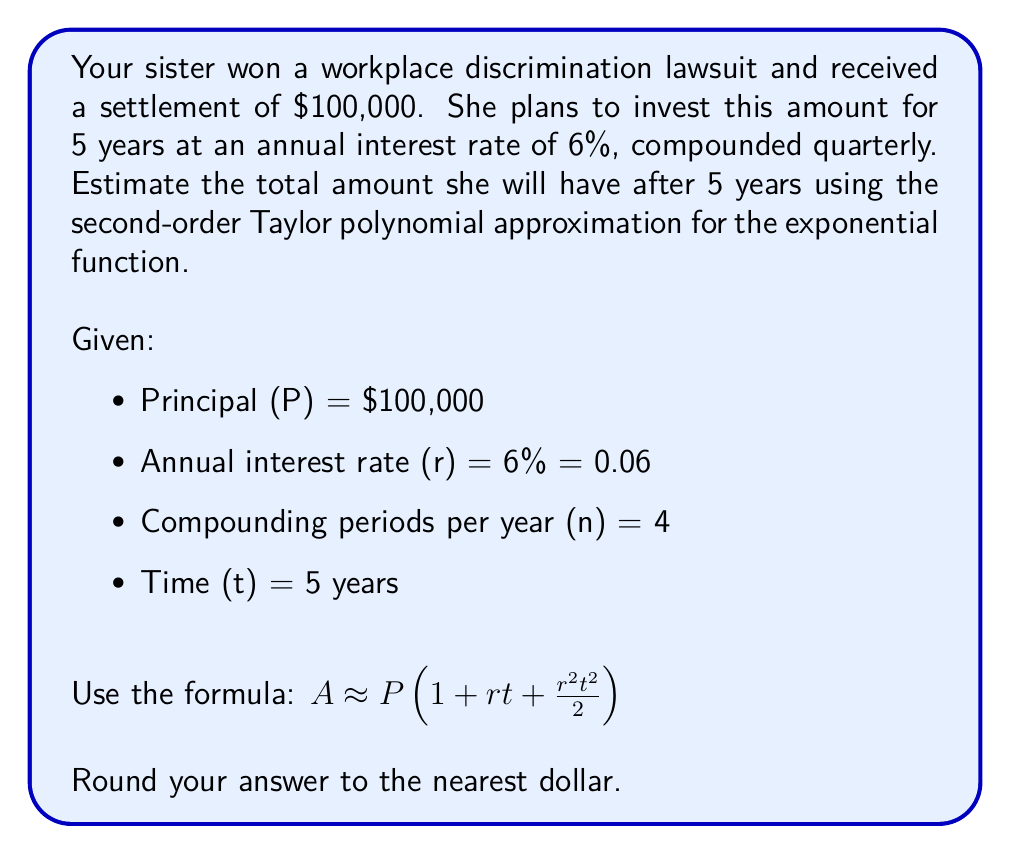Could you help me with this problem? To solve this problem, we'll use the second-order Taylor polynomial approximation for the compound interest formula. Here's the step-by-step solution:

1) The standard compound interest formula is:
   $$A = P(1 + \frac{r}{n})^{nt}$$

2) The second-order Taylor polynomial approximation for this is:
   $$A \approx P(1 + rt + \frac{r^2t^2}{2})$$

3) Let's substitute the given values:
   P = $100,000
   r = 0.06
   t = 5

4) Now, let's calculate:
   $$A \approx 100,000(1 + 0.06 * 5 + \frac{0.06^2 * 5^2}{2})$$

5) Simplify:
   $$A \approx 100,000(1 + 0.3 + \frac{0.0036 * 25}{2})$$
   $$A \approx 100,000(1 + 0.3 + 0.045)$$
   $$A \approx 100,000(1.345)$$

6) Calculate the final amount:
   $$A \approx 134,500$$

7) Rounding to the nearest dollar:
   A ≈ $134,500

This approximation provides an estimate of the total amount after 5 years, considering compound interest.
Answer: $134,500 